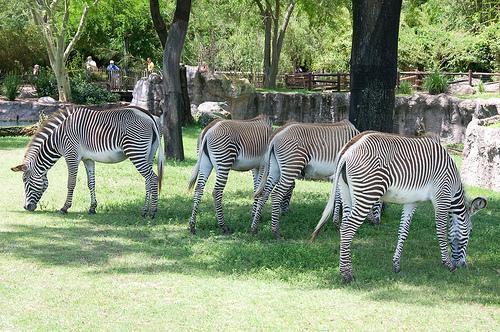How many zebras are there?
Give a very brief answer. 4. How many trees are there?
Give a very brief answer. 4. How many legs does the zebra have?
Give a very brief answer. 4. 